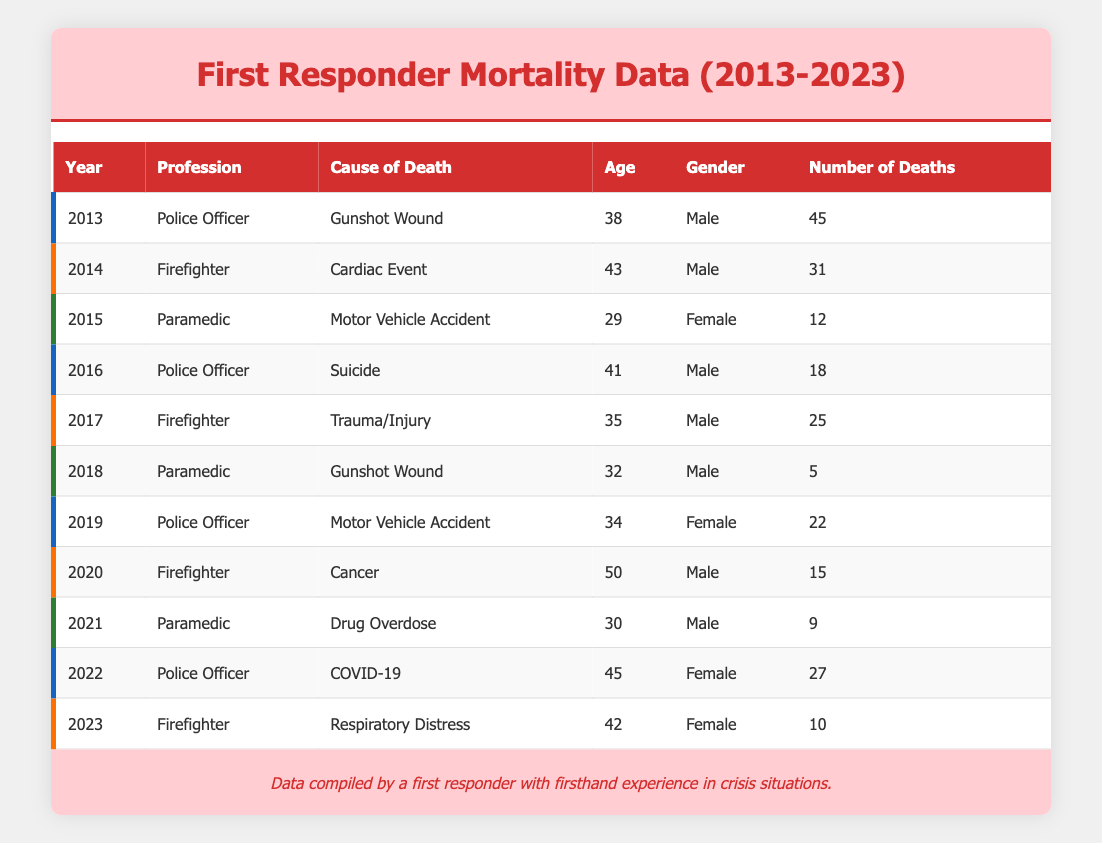What was the cause of death for the firefighter in 2014? The table shows that in 2014, the cause of death for the firefighter was a cardiac event. This is directly referenced in the row corresponding to the year 2014.
Answer: Cardiac Event How many deaths were reported for police officers in total between 2013 and 2022? To find the total, I will sum the number of deaths for police officers from the years 2013 (45), 2016 (18), 2019 (22), and 2022 (27). So the total is 45 + 18 + 22 + 27 = 112.
Answer: 112 Which profession had the highest number of deaths from motor vehicle accidents? Reviewing the table, there are two entries for motor vehicle accidents: one for a paramedic in 2015 (12 deaths) and one for a police officer in 2019 (22 deaths). The police officer had the highest number with 22 deaths.
Answer: Police Officer In 2020, how many firefighters died from causes other than cancer? According to the table, in 2020, the only cause of death for firefighters was cancer, which had 15 reported deaths. Since there are no other listed causes for that year, the number of deaths from other causes is zero.
Answer: 0 Was there a year when a paramedic died from a gunshot wound? Yes, the table indicates that a paramedic died from a gunshot wound in the year 2018 (5 deaths). I located this entry specifically under the profession of paramedic for that year.
Answer: Yes What is the average age of firefighters who died from respiratory distress in the last decade? The data shows that in 2023, a firefighter who died from respiratory distress was 42 years old. Since this is the only entry that falls into this category, the average age is simply the age of that single entry, which is 42.
Answer: 42 Which cause of death had the least number of total deaths across all professions in the years provided? By examining the table for total deaths by cause, we see the following: gunshot wound (45 + 5 = 50), cardiac event (31), motor vehicle accident (12 + 22 = 34), suicide (18), trauma/injury (25), cancer (15), drug overdose (9), and respiratory distress (10). The least was drug overdose with 9 deaths.
Answer: Drug Overdose How many female paramedics died due to drug overdose in 2021? In the table, there is one entry for 2021 under the paramedic profession with a cause of death listed as a drug overdose, and it indicates that the individual was male. Therefore, the number of female paramedics who died from drug overdose in that year is zero.
Answer: 0 